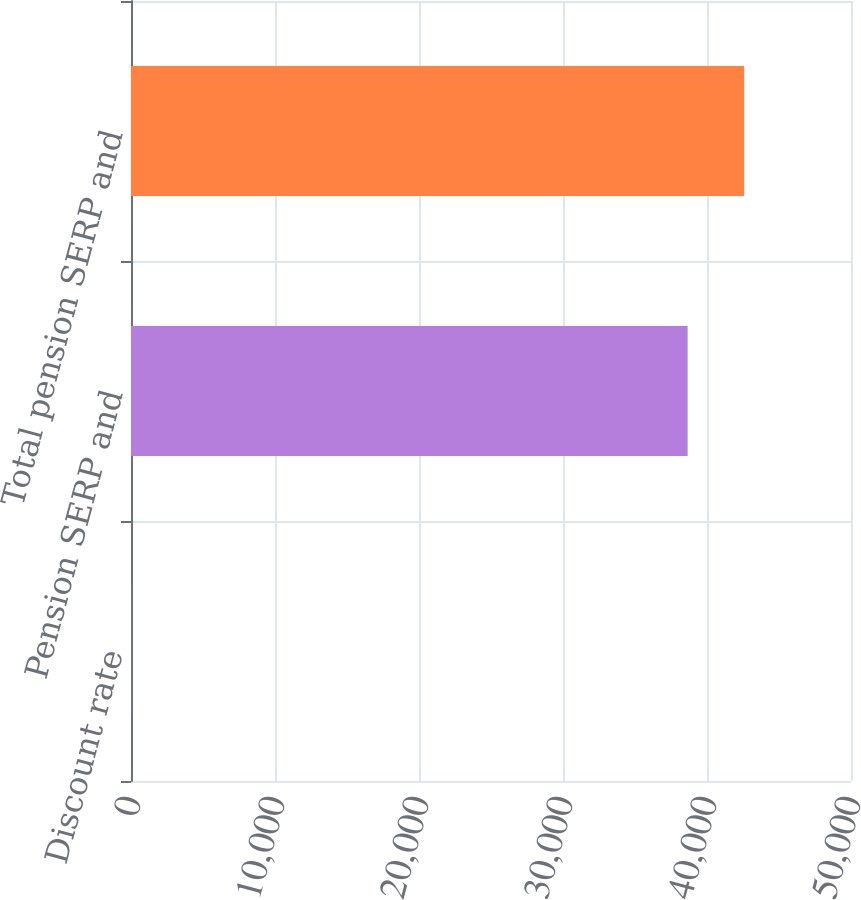Convert chart. <chart><loc_0><loc_0><loc_500><loc_500><bar_chart><fcel>Discount rate<fcel>Pension SERP and<fcel>Total pension SERP and<nl><fcel>4.98<fcel>38655<fcel>42589.3<nl></chart> 